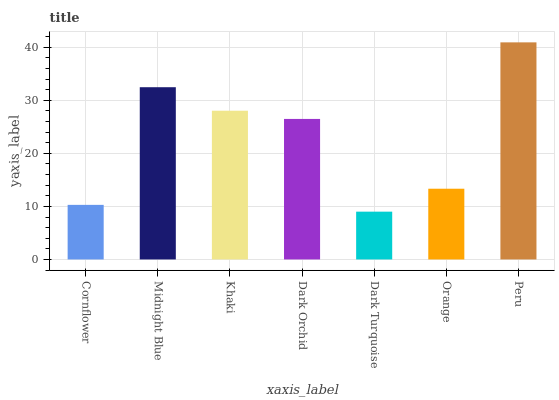Is Dark Turquoise the minimum?
Answer yes or no. Yes. Is Peru the maximum?
Answer yes or no. Yes. Is Midnight Blue the minimum?
Answer yes or no. No. Is Midnight Blue the maximum?
Answer yes or no. No. Is Midnight Blue greater than Cornflower?
Answer yes or no. Yes. Is Cornflower less than Midnight Blue?
Answer yes or no. Yes. Is Cornflower greater than Midnight Blue?
Answer yes or no. No. Is Midnight Blue less than Cornflower?
Answer yes or no. No. Is Dark Orchid the high median?
Answer yes or no. Yes. Is Dark Orchid the low median?
Answer yes or no. Yes. Is Dark Turquoise the high median?
Answer yes or no. No. Is Peru the low median?
Answer yes or no. No. 